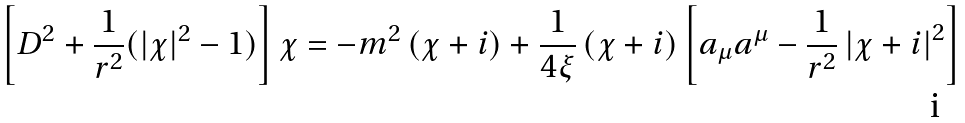Convert formula to latex. <formula><loc_0><loc_0><loc_500><loc_500>\left [ D ^ { 2 } + \frac { 1 } { r ^ { 2 } } ( | \chi | ^ { 2 } - 1 ) \right ] \chi = - m ^ { 2 } \left ( \chi + i \right ) + \frac { 1 } { 4 \xi } \left ( \chi + i \right ) \left [ a _ { \mu } a ^ { \mu } - \frac { 1 } { r ^ { 2 } } \left | \chi + i \right | ^ { 2 } \right ]</formula> 